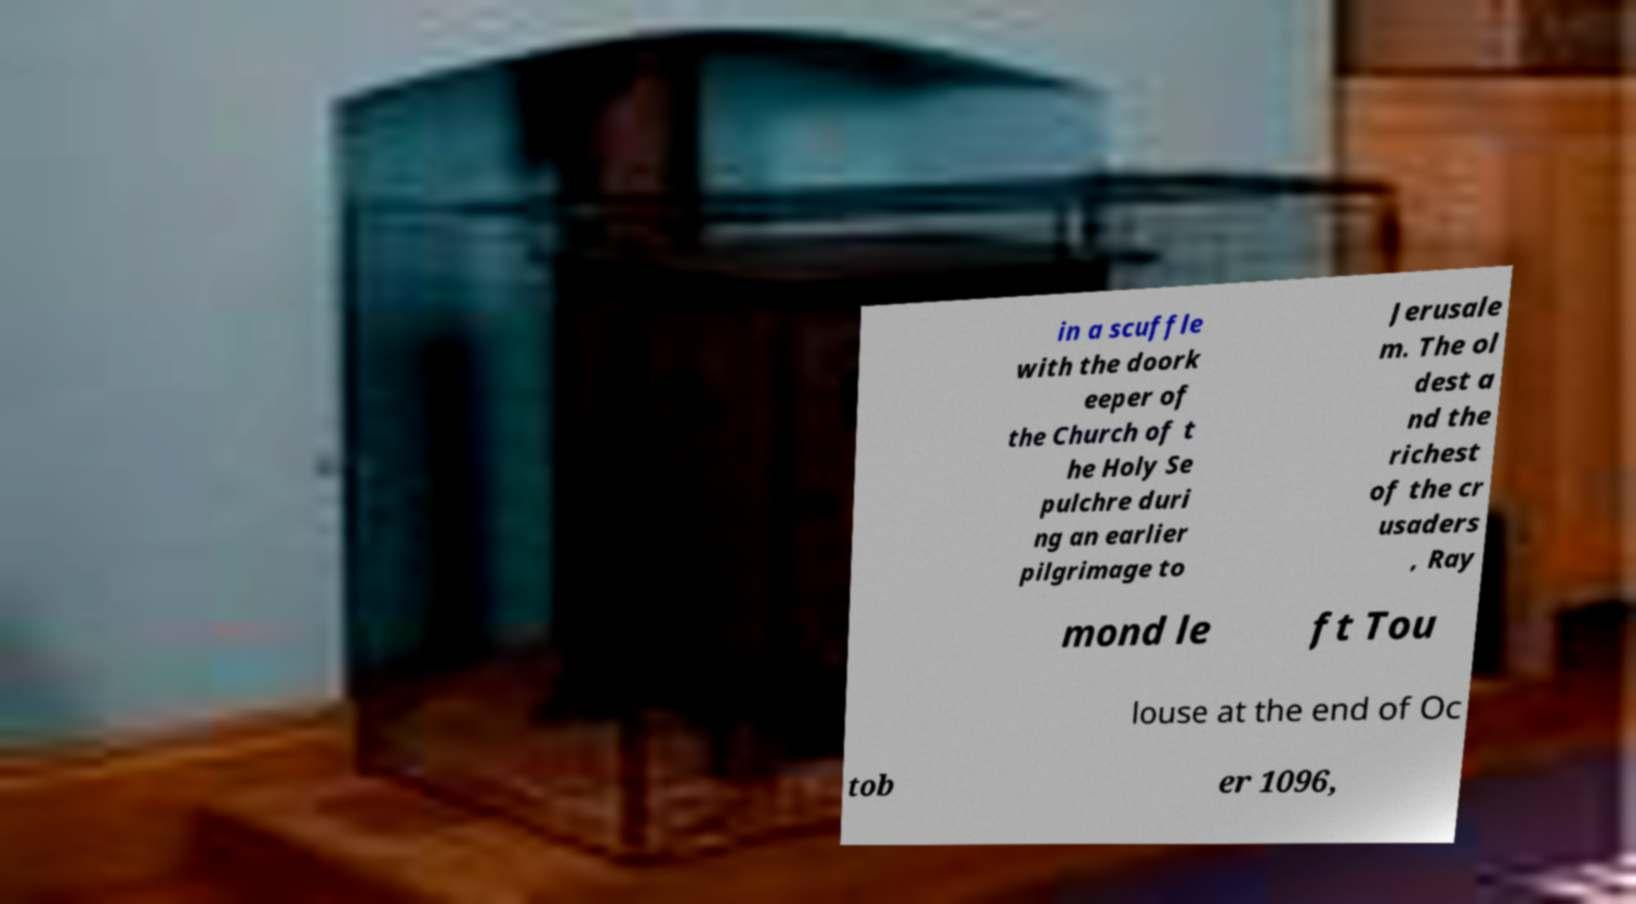There's text embedded in this image that I need extracted. Can you transcribe it verbatim? in a scuffle with the doork eeper of the Church of t he Holy Se pulchre duri ng an earlier pilgrimage to Jerusale m. The ol dest a nd the richest of the cr usaders , Ray mond le ft Tou louse at the end of Oc tob er 1096, 